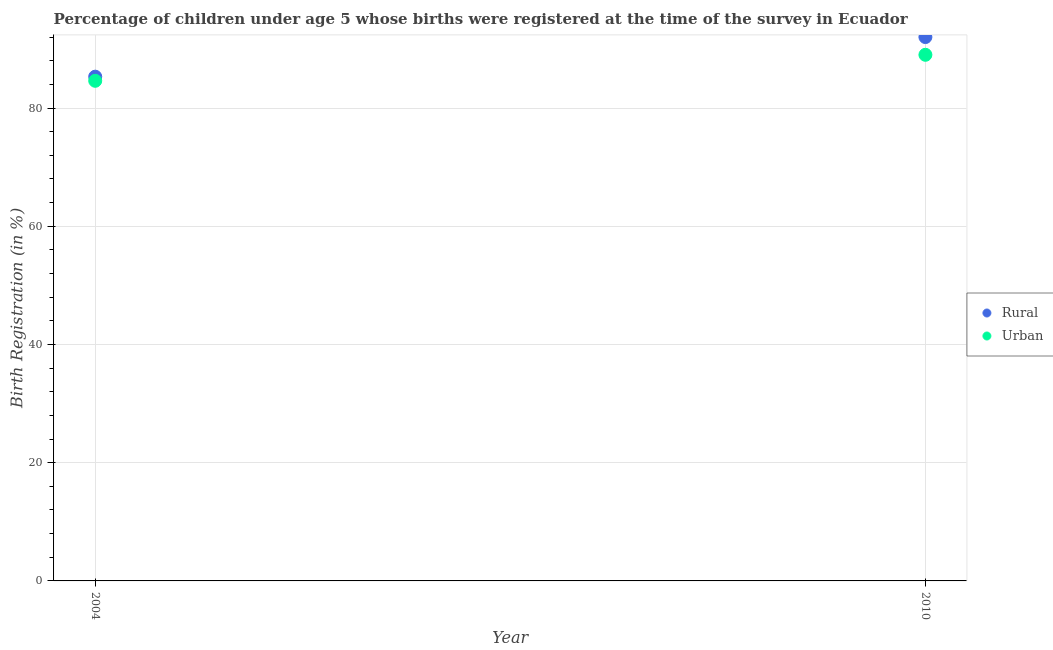What is the rural birth registration in 2010?
Make the answer very short. 92. Across all years, what is the maximum rural birth registration?
Ensure brevity in your answer.  92. Across all years, what is the minimum rural birth registration?
Ensure brevity in your answer.  85.3. In which year was the rural birth registration minimum?
Make the answer very short. 2004. What is the total urban birth registration in the graph?
Offer a terse response. 173.6. What is the difference between the rural birth registration in 2004 and that in 2010?
Offer a terse response. -6.7. What is the difference between the urban birth registration in 2010 and the rural birth registration in 2004?
Offer a very short reply. 3.7. What is the average rural birth registration per year?
Offer a very short reply. 88.65. What is the ratio of the rural birth registration in 2004 to that in 2010?
Provide a short and direct response. 0.93. Does the urban birth registration monotonically increase over the years?
Ensure brevity in your answer.  Yes. Is the urban birth registration strictly greater than the rural birth registration over the years?
Your response must be concise. No. Is the rural birth registration strictly less than the urban birth registration over the years?
Offer a terse response. No. How many dotlines are there?
Offer a terse response. 2. How many years are there in the graph?
Make the answer very short. 2. What is the difference between two consecutive major ticks on the Y-axis?
Ensure brevity in your answer.  20. Are the values on the major ticks of Y-axis written in scientific E-notation?
Ensure brevity in your answer.  No. Does the graph contain any zero values?
Offer a very short reply. No. Where does the legend appear in the graph?
Your response must be concise. Center right. How many legend labels are there?
Your answer should be compact. 2. What is the title of the graph?
Keep it short and to the point. Percentage of children under age 5 whose births were registered at the time of the survey in Ecuador. Does "RDB nonconcessional" appear as one of the legend labels in the graph?
Make the answer very short. No. What is the label or title of the Y-axis?
Your response must be concise. Birth Registration (in %). What is the Birth Registration (in %) in Rural in 2004?
Ensure brevity in your answer.  85.3. What is the Birth Registration (in %) of Urban in 2004?
Your response must be concise. 84.6. What is the Birth Registration (in %) in Rural in 2010?
Ensure brevity in your answer.  92. What is the Birth Registration (in %) in Urban in 2010?
Give a very brief answer. 89. Across all years, what is the maximum Birth Registration (in %) in Rural?
Provide a succinct answer. 92. Across all years, what is the maximum Birth Registration (in %) of Urban?
Provide a succinct answer. 89. Across all years, what is the minimum Birth Registration (in %) in Rural?
Ensure brevity in your answer.  85.3. Across all years, what is the minimum Birth Registration (in %) in Urban?
Give a very brief answer. 84.6. What is the total Birth Registration (in %) in Rural in the graph?
Your response must be concise. 177.3. What is the total Birth Registration (in %) in Urban in the graph?
Your response must be concise. 173.6. What is the difference between the Birth Registration (in %) of Urban in 2004 and that in 2010?
Make the answer very short. -4.4. What is the average Birth Registration (in %) in Rural per year?
Your answer should be very brief. 88.65. What is the average Birth Registration (in %) in Urban per year?
Provide a short and direct response. 86.8. In the year 2004, what is the difference between the Birth Registration (in %) in Rural and Birth Registration (in %) in Urban?
Your answer should be very brief. 0.7. What is the ratio of the Birth Registration (in %) in Rural in 2004 to that in 2010?
Make the answer very short. 0.93. What is the ratio of the Birth Registration (in %) in Urban in 2004 to that in 2010?
Give a very brief answer. 0.95. What is the difference between the highest and the second highest Birth Registration (in %) in Rural?
Your answer should be compact. 6.7. What is the difference between the highest and the lowest Birth Registration (in %) in Urban?
Your answer should be very brief. 4.4. 